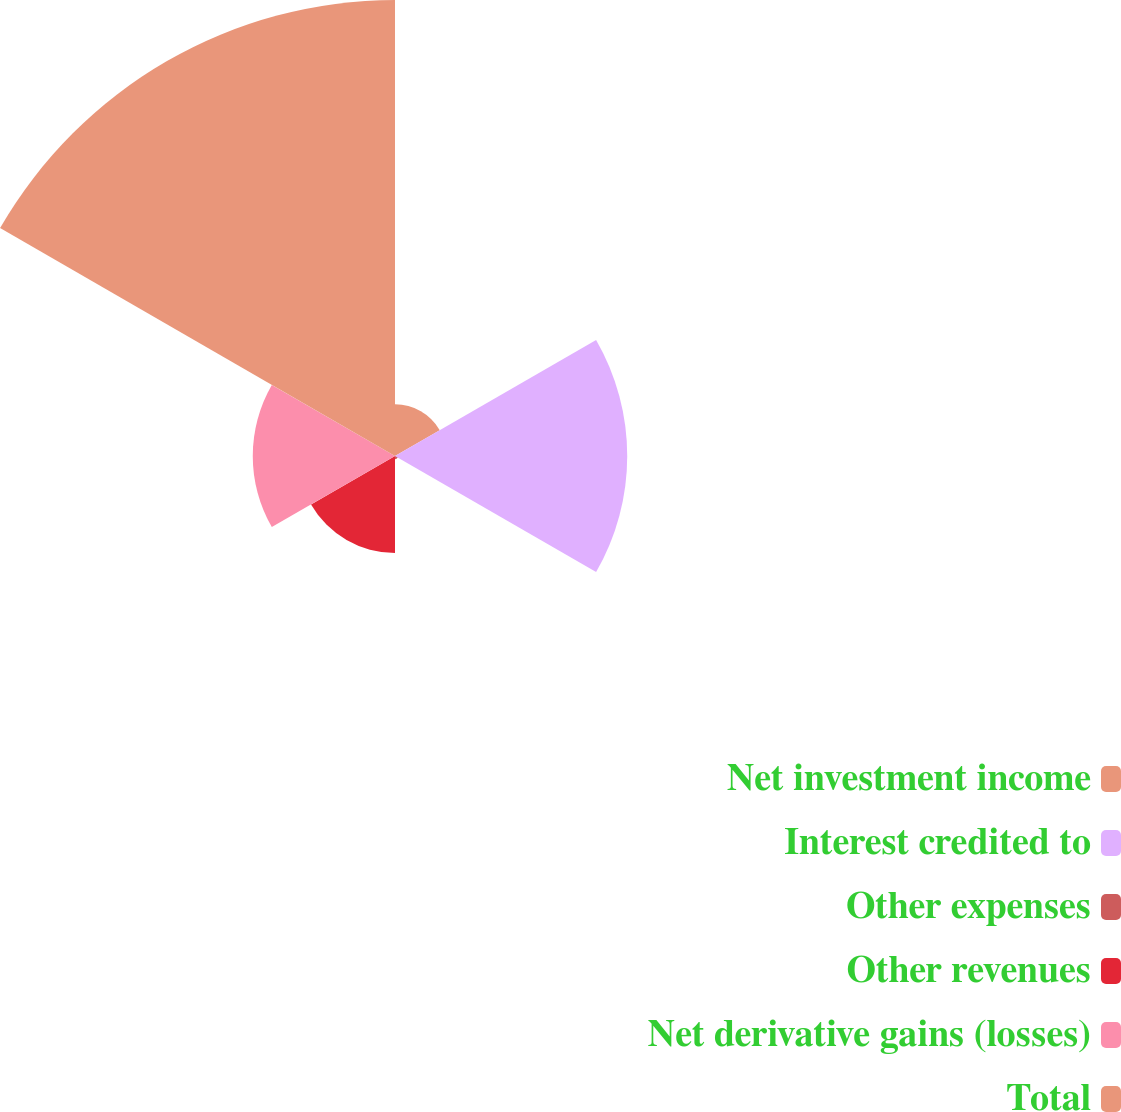<chart> <loc_0><loc_0><loc_500><loc_500><pie_chart><fcel>Net investment income<fcel>Interest credited to<fcel>Other expenses<fcel>Other revenues<fcel>Net derivative gains (losses)<fcel>Total<nl><fcel>5.26%<fcel>23.64%<fcel>0.32%<fcel>9.87%<fcel>14.48%<fcel>46.42%<nl></chart> 